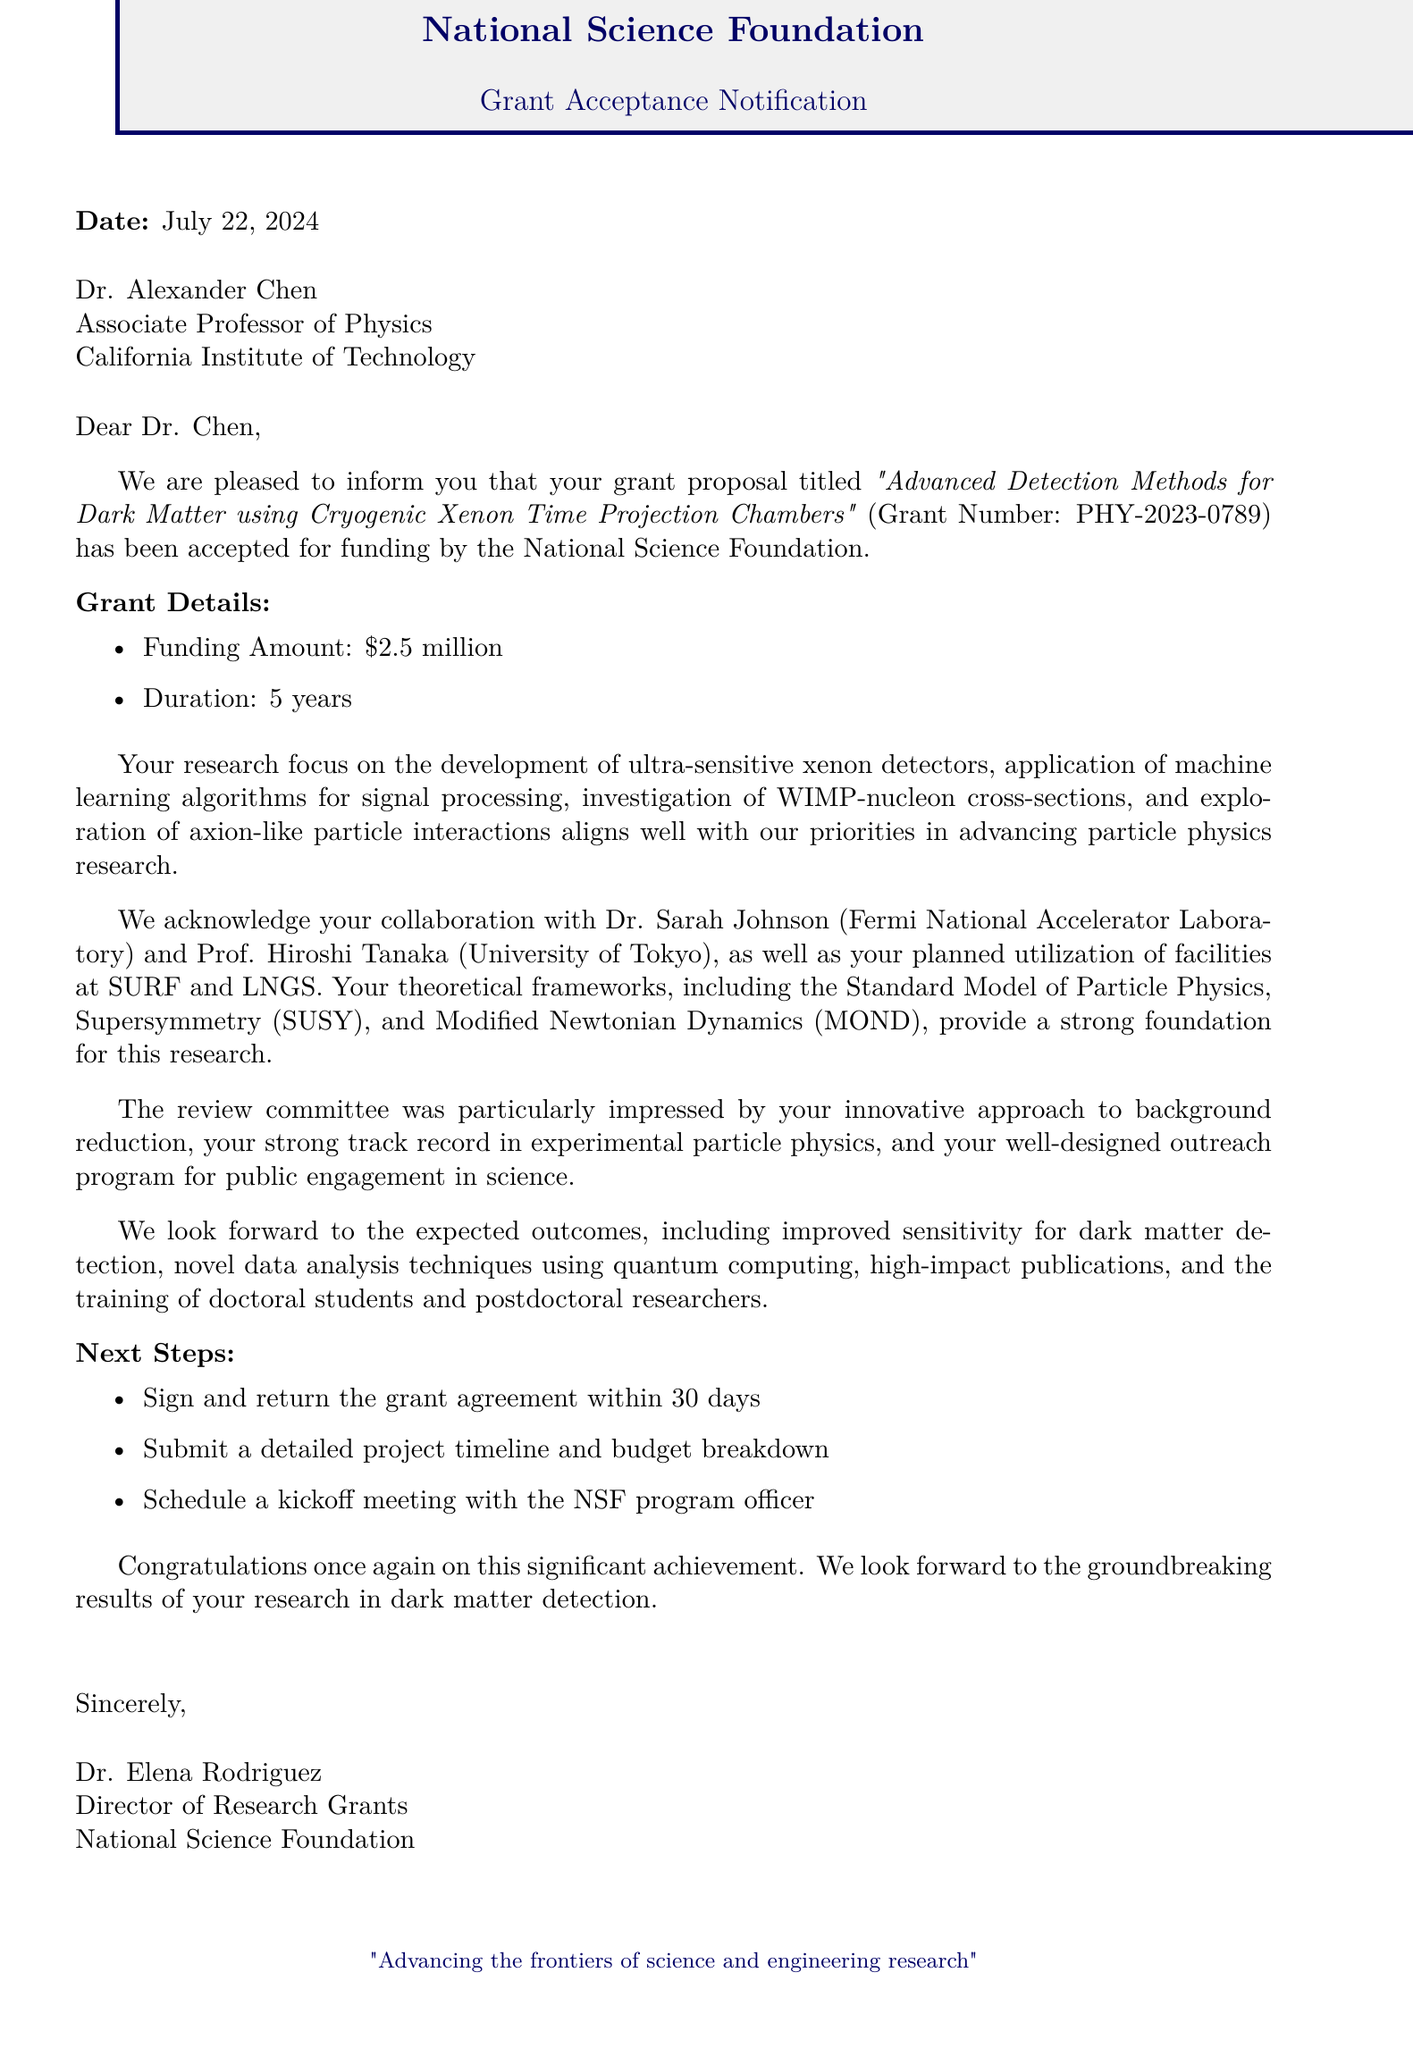What is the grant number? The grant number is stated in the document as PHY-2023-0789.
Answer: PHY-2023-0789 Who is the director of research grants? The document names Dr. Elena Rodriguez as the director of research grants.
Answer: Dr. Elena Rodriguez What is the total funding amount for the grant? The funding amount is specified in the document as $2.5 million.
Answer: $2.5 million What is the duration of the grant? The duration of the grant is mentioned in the document as 5 years.
Answer: 5 years Which two institutions are collaborating in this research? The collaborators listed in the document are Fermi National Accelerator Laboratory and University of Tokyo.
Answer: Fermi National Accelerator Laboratory and University of Tokyo What is a key expected outcome of the research stated in the document? The expected outcomes include improved sensitivity for dark matter detection, which is specified in the document.
Answer: Improved sensitivity for dark matter detection What is one of the theoretical frameworks mentioned in the letter? The document refers to the Standard Model of Particle Physics as a theoretical framework.
Answer: Standard Model of Particle Physics What committee feedback was highlighted regarding the proposal? The review committee noted the innovative approach to background reduction in the feedback.
Answer: Innovative approach to background reduction What is the first next step mentioned for the grant acceptance? The document states the first next step is to sign and return the grant agreement within 30 days.
Answer: Sign and return the grant agreement within 30 days 